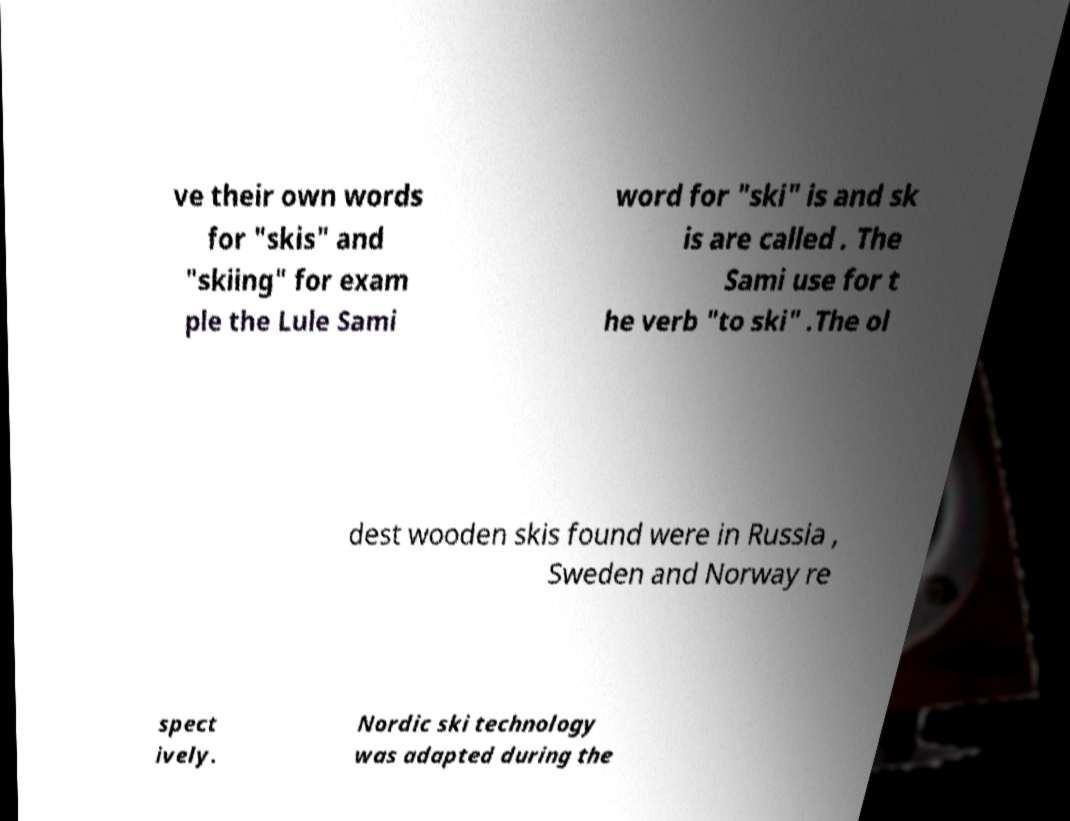Could you assist in decoding the text presented in this image and type it out clearly? ve their own words for "skis" and "skiing" for exam ple the Lule Sami word for "ski" is and sk is are called . The Sami use for t he verb "to ski" .The ol dest wooden skis found were in Russia , Sweden and Norway re spect ively. Nordic ski technology was adapted during the 